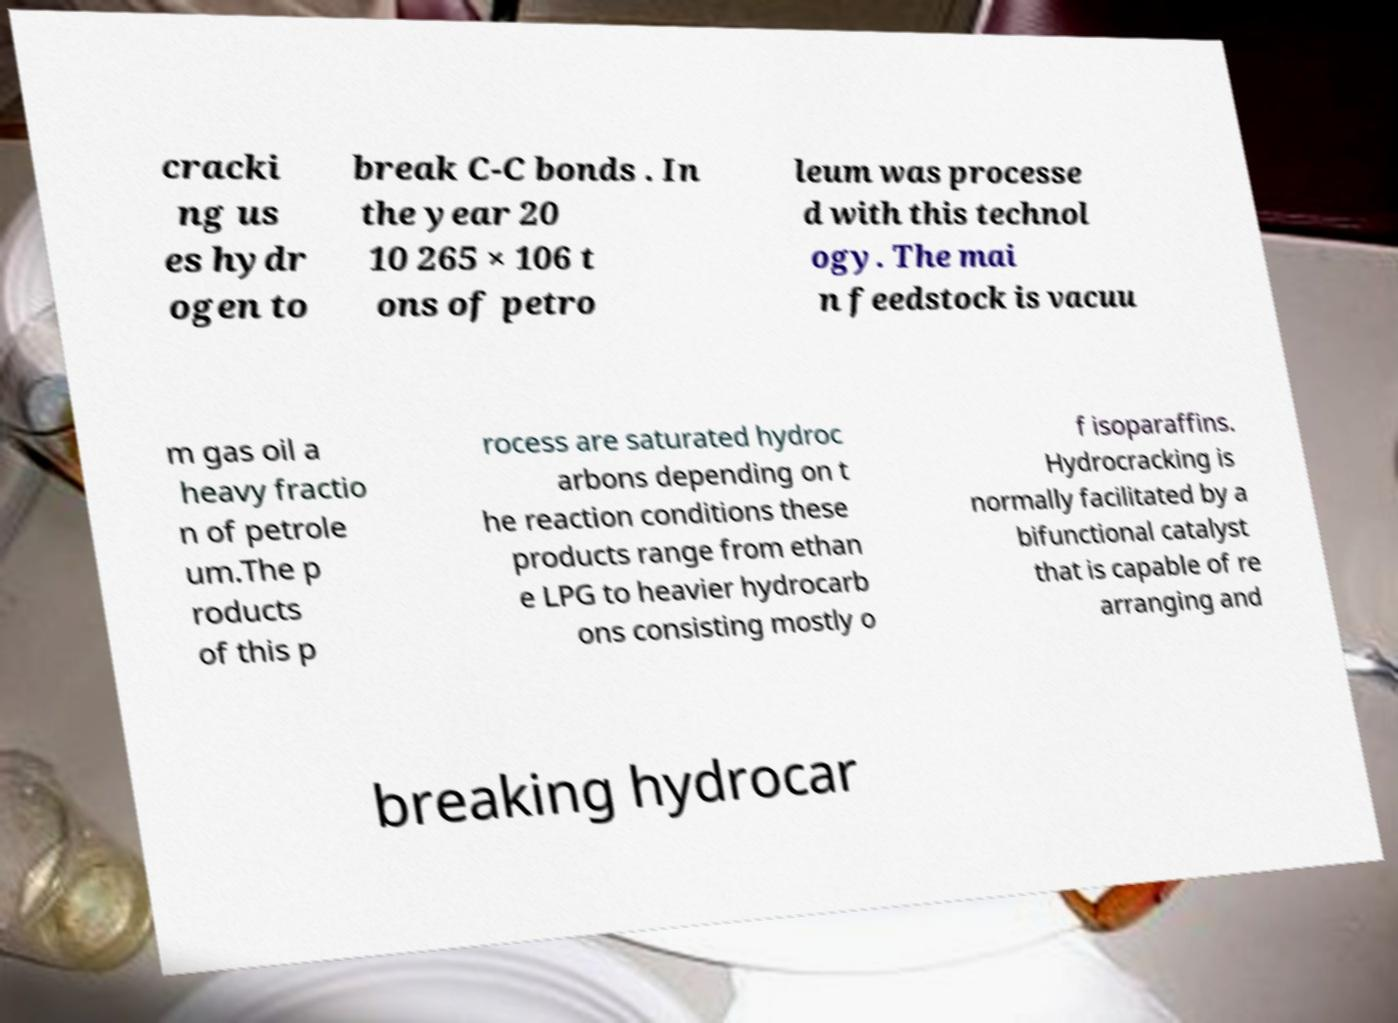For documentation purposes, I need the text within this image transcribed. Could you provide that? cracki ng us es hydr ogen to break C-C bonds . In the year 20 10 265 × 106 t ons of petro leum was processe d with this technol ogy. The mai n feedstock is vacuu m gas oil a heavy fractio n of petrole um.The p roducts of this p rocess are saturated hydroc arbons depending on t he reaction conditions these products range from ethan e LPG to heavier hydrocarb ons consisting mostly o f isoparaffins. Hydrocracking is normally facilitated by a bifunctional catalyst that is capable of re arranging and breaking hydrocar 